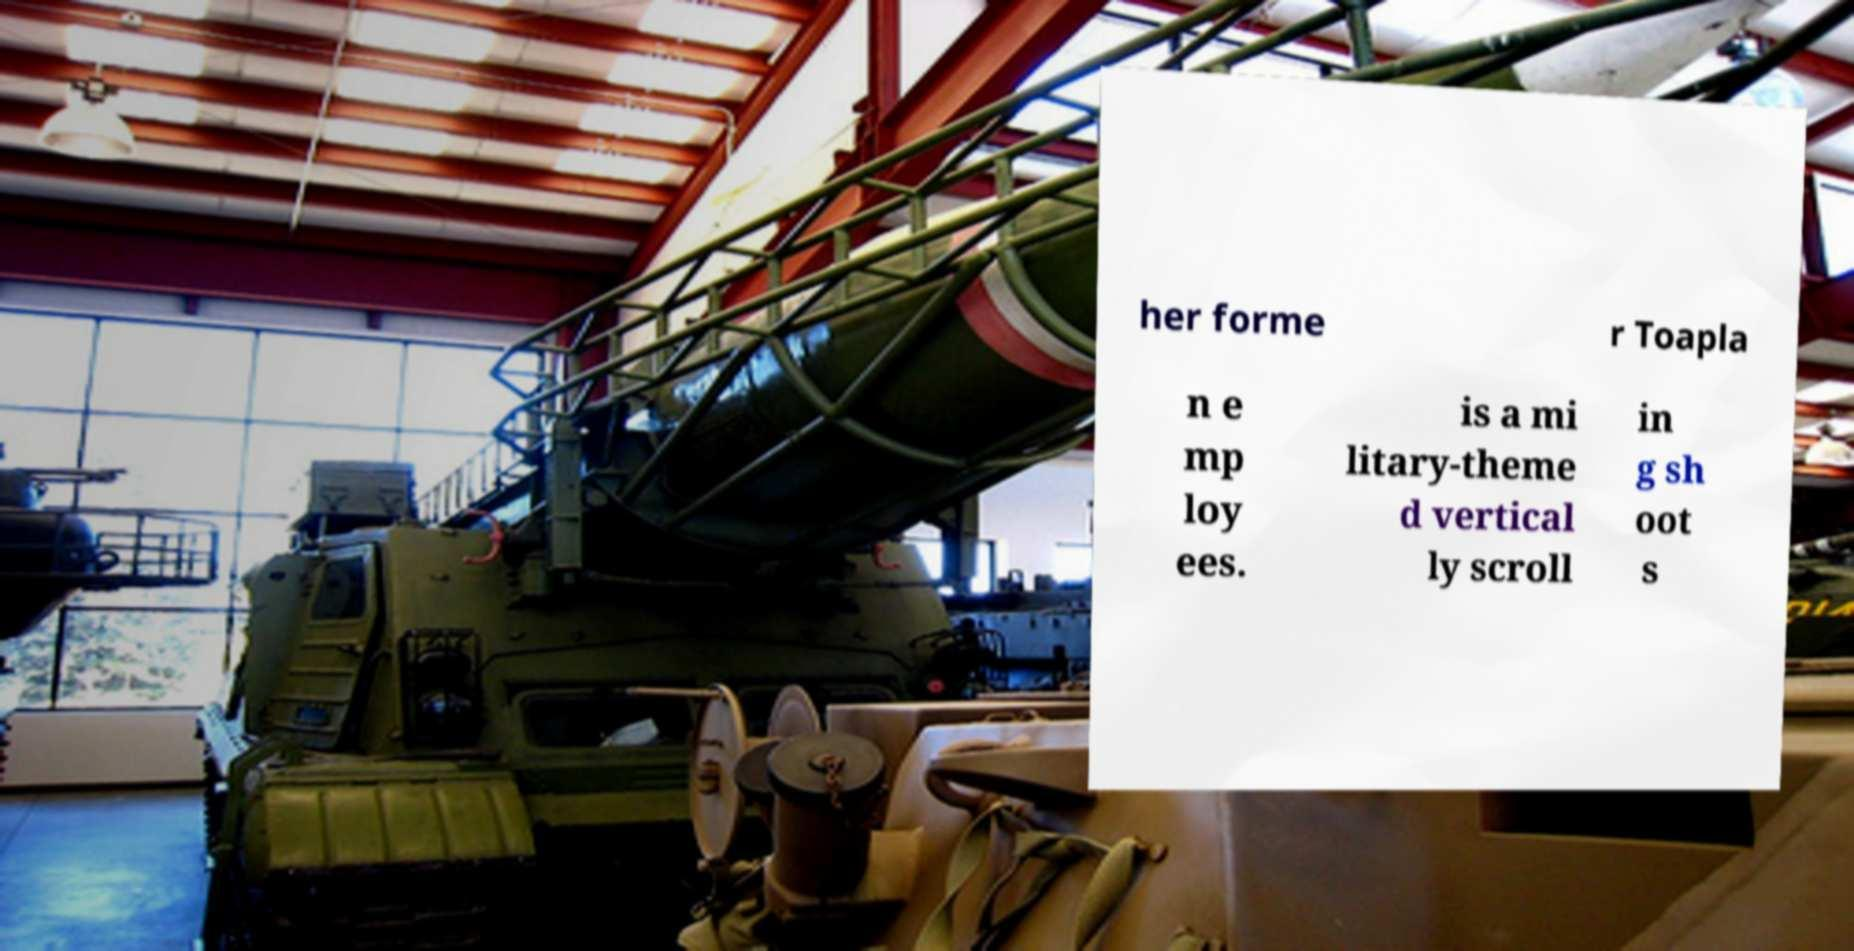For documentation purposes, I need the text within this image transcribed. Could you provide that? her forme r Toapla n e mp loy ees. is a mi litary-theme d vertical ly scroll in g sh oot s 